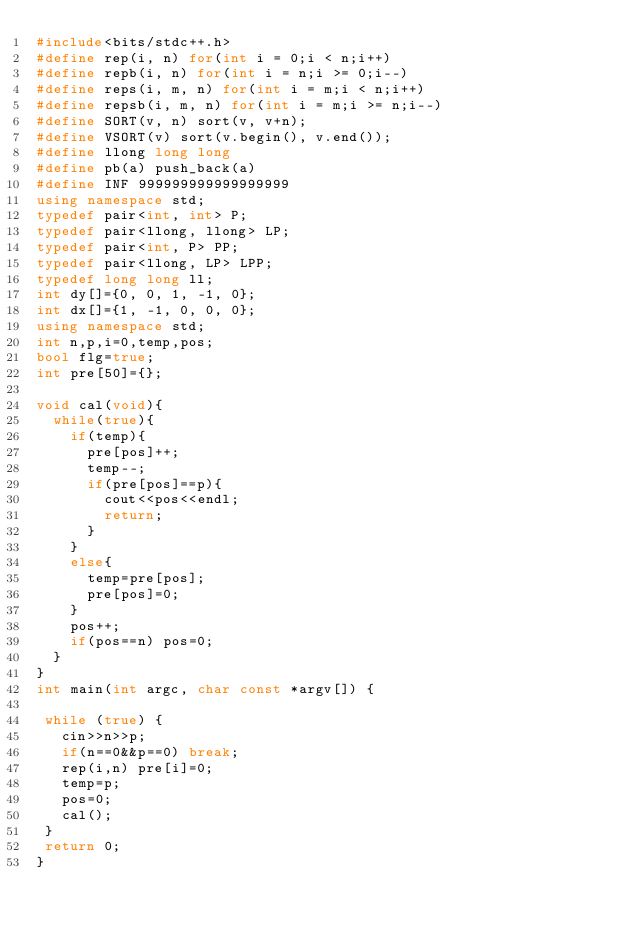<code> <loc_0><loc_0><loc_500><loc_500><_C++_>#include<bits/stdc++.h>
#define rep(i, n) for(int i = 0;i < n;i++)
#define repb(i, n) for(int i = n;i >= 0;i--)
#define reps(i, m, n) for(int i = m;i < n;i++)
#define repsb(i, m, n) for(int i = m;i >= n;i--)
#define SORT(v, n) sort(v, v+n);
#define VSORT(v) sort(v.begin(), v.end());
#define llong long long
#define pb(a) push_back(a)
#define INF 999999999999999999
using namespace std;
typedef pair<int, int> P;
typedef pair<llong, llong> LP;
typedef pair<int, P> PP;
typedef pair<llong, LP> LPP;
typedef long long ll;
int dy[]={0, 0, 1, -1, 0};
int dx[]={1, -1, 0, 0, 0};
using namespace std;
int n,p,i=0,temp,pos;
bool flg=true;
int pre[50]={};

void cal(void){
  while(true){
    if(temp){
      pre[pos]++;
      temp--;
      if(pre[pos]==p){
        cout<<pos<<endl;
        return;
      }
    }
    else{
      temp=pre[pos];
      pre[pos]=0;
    }
    pos++;
    if(pos==n) pos=0;
  }
}
int main(int argc, char const *argv[]) {

 while (true) {
   cin>>n>>p;
   if(n==0&&p==0) break;
   rep(i,n) pre[i]=0;
   temp=p;
   pos=0;
   cal();
 }
 return 0;
}

</code> 